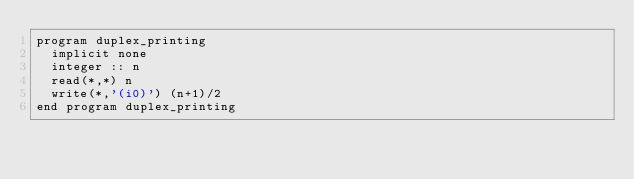<code> <loc_0><loc_0><loc_500><loc_500><_FORTRAN_>program duplex_printing
  implicit none
  integer :: n
  read(*,*) n
  write(*,'(i0)') (n+1)/2
end program duplex_printing</code> 